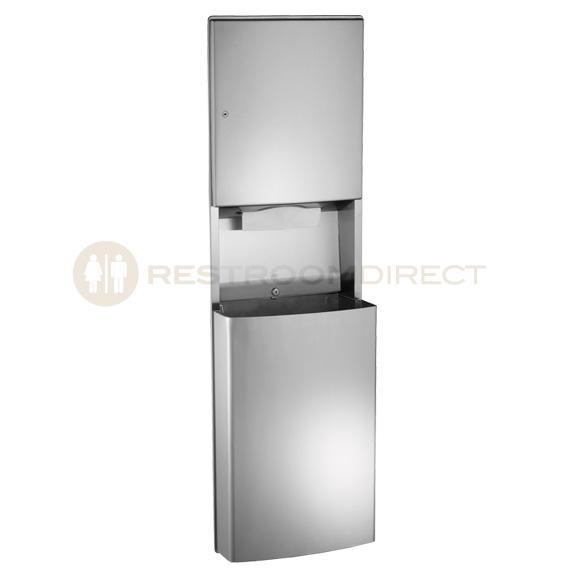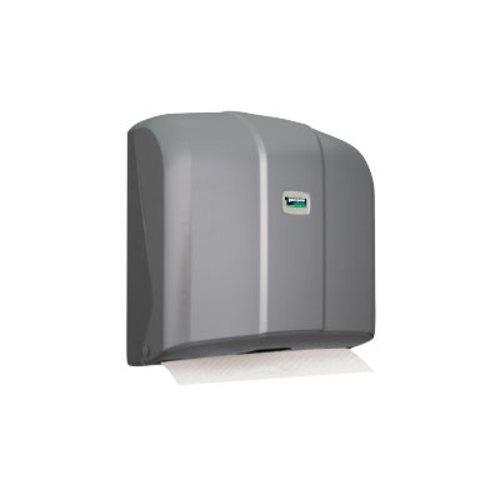The first image is the image on the left, the second image is the image on the right. Considering the images on both sides, is "Both dispensers are rectangular in shape." valid? Answer yes or no. No. The first image is the image on the left, the second image is the image on the right. For the images shown, is this caption "Each image shows a rectangular tray-type container holding a stack of folded paper towels." true? Answer yes or no. No. 